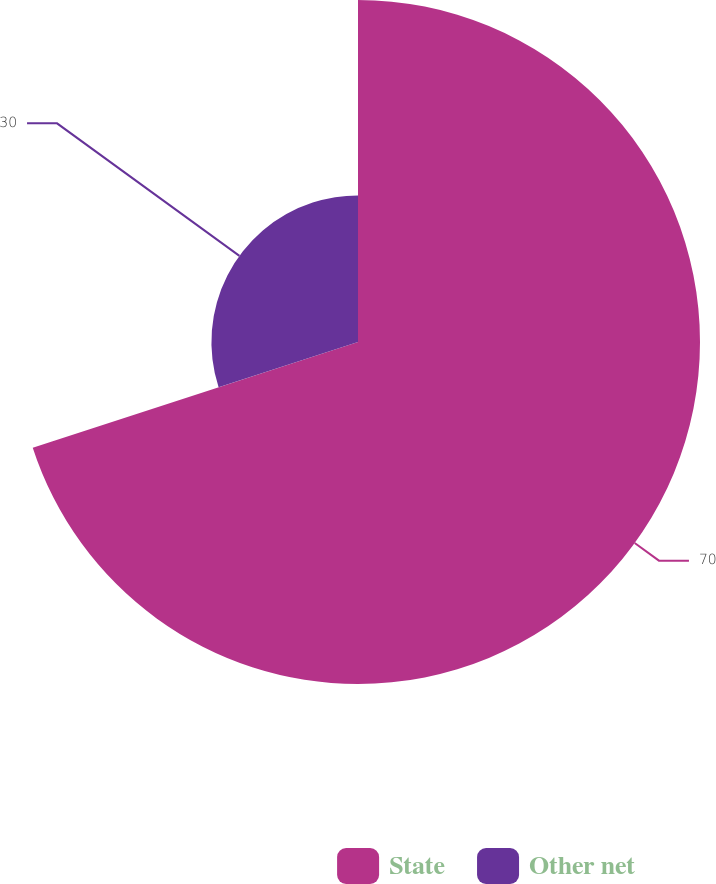Convert chart to OTSL. <chart><loc_0><loc_0><loc_500><loc_500><pie_chart><fcel>State<fcel>Other net<nl><fcel>70.0%<fcel>30.0%<nl></chart> 